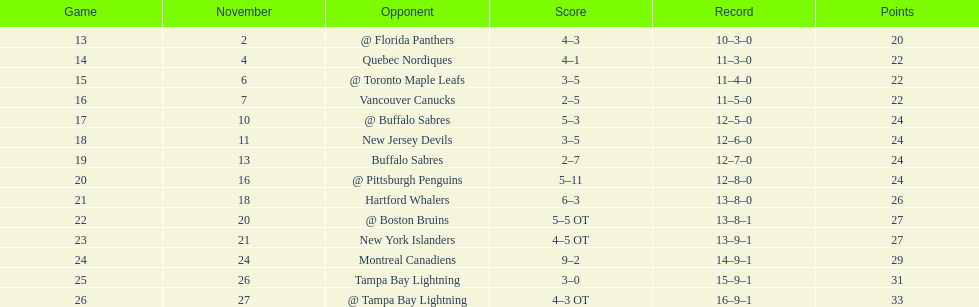During the 1993-1994 season in the atlantic division, which team was the only one to have fewer points than the philadelphia flyers? Tampa Bay Lightning. 